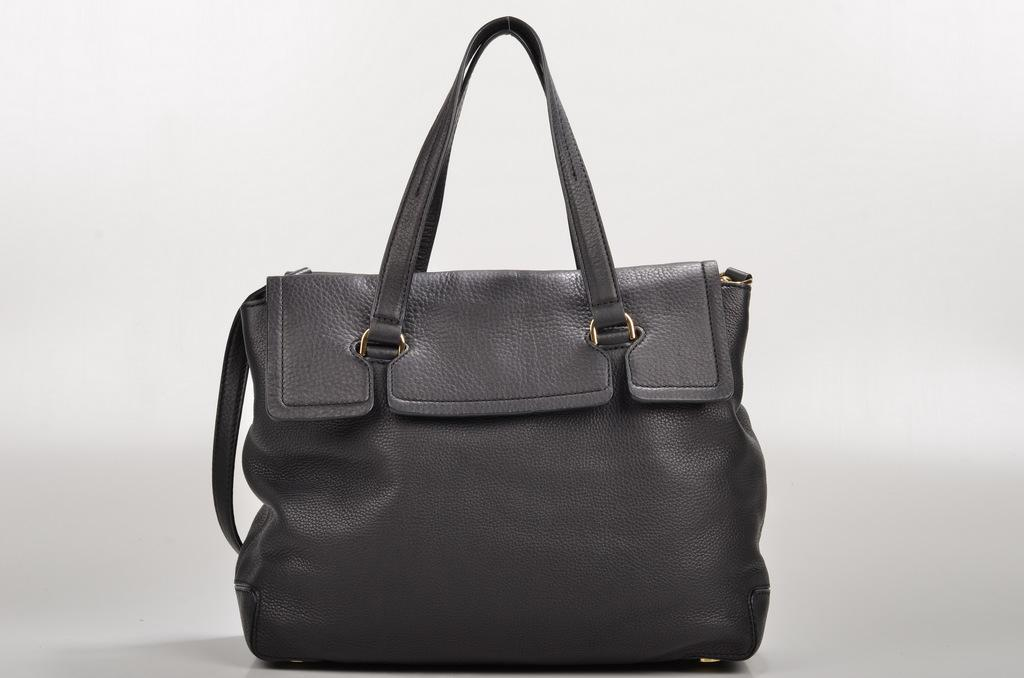What is located in the middle of the image? There is a bag in the middle of the image. What feature does the bag have? The bag has a handle. Where is the father standing in the image? There is no father present in the image; it only features a bag with a handle. What type of stocking is hanging on the wall in the image? There is no stocking or wall present in the image; it only features a bag with a handle. 